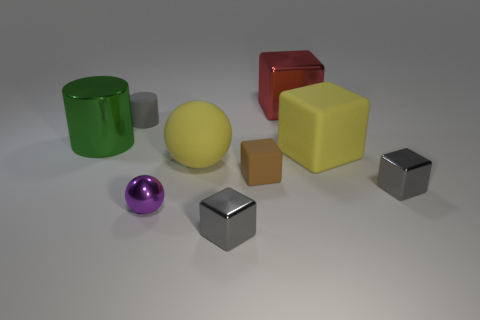Subtract all green cylinders. How many cylinders are left? 1 Subtract all yellow rubber cubes. How many cubes are left? 4 Subtract all cubes. How many objects are left? 4 Add 1 large yellow blocks. How many large yellow blocks are left? 2 Add 4 tiny green matte things. How many tiny green matte things exist? 4 Subtract 1 gray cylinders. How many objects are left? 8 Subtract 1 cylinders. How many cylinders are left? 1 Subtract all blue balls. Subtract all cyan cylinders. How many balls are left? 2 Subtract all gray spheres. How many gray blocks are left? 2 Subtract all large green shiny spheres. Subtract all big yellow things. How many objects are left? 7 